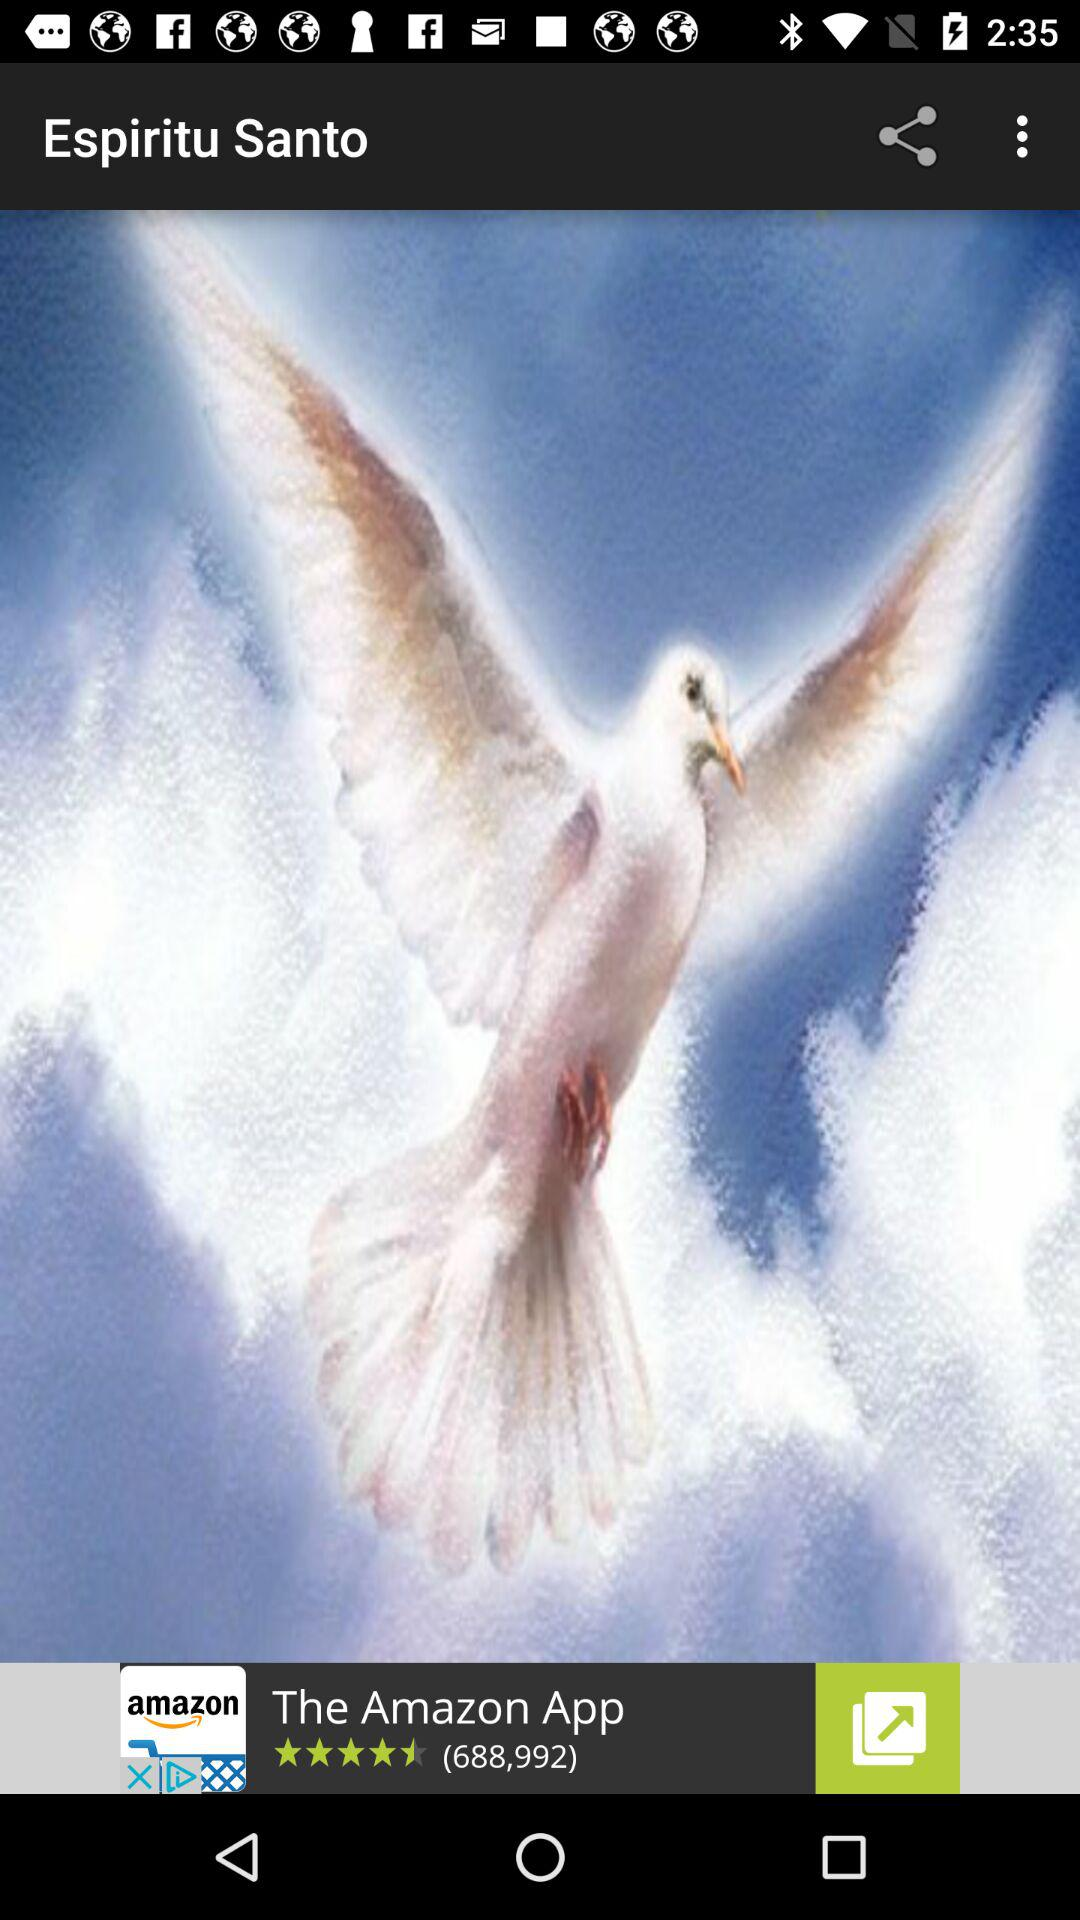What is the name of the application? The name of the application is "Espiritu Santo". 